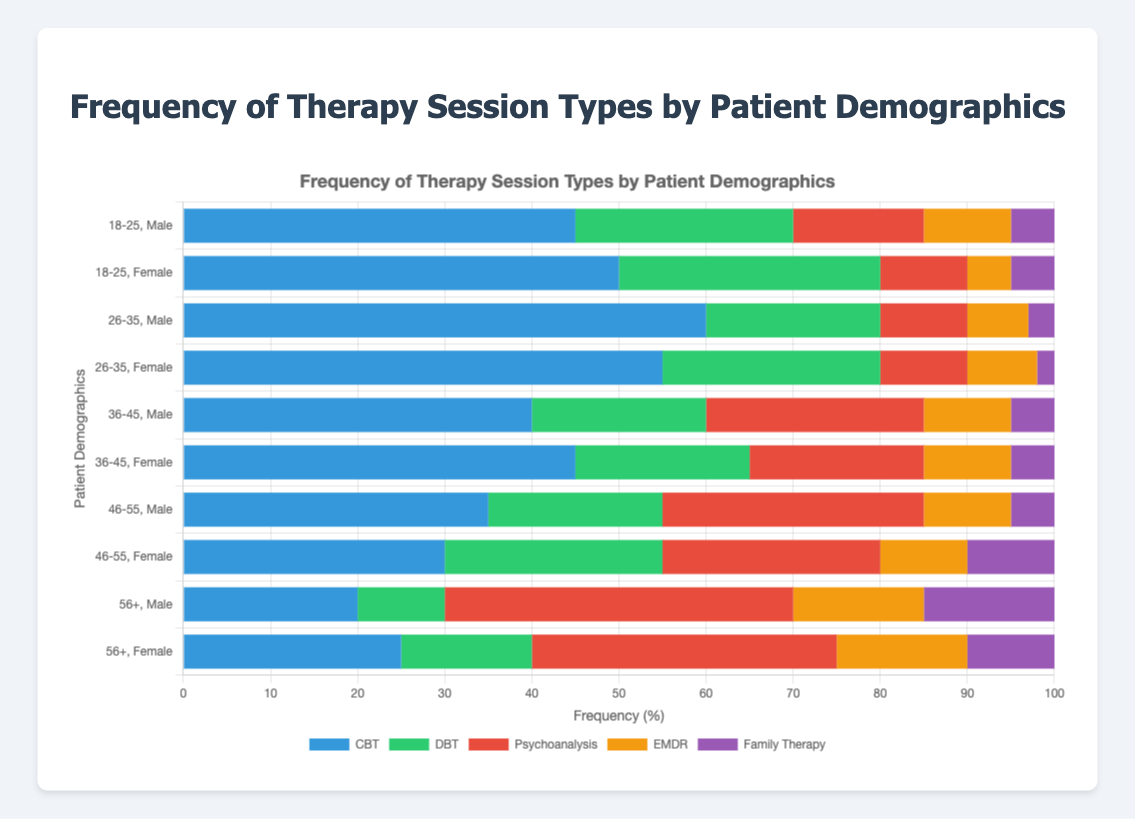What is the most common therapy type for males aged 26-35? To determine the most common therapy type for males aged 26-35, examine the bar length corresponding to each therapy for this demographic and identify the longest one. In this case, the longest bar is for CBT.
Answer: CBT How many more therapy sessions of CBT do females aged 18-25 attend compared to males aged 18-25? First, find the number of CBT sessions for females aged 18-25 (50) and males aged 18-25 (45). Then subtract the latter from the former (50 - 45 = 5).
Answer: 5 Which gender in the 36-45 age group has a higher frequency of Psychoanalysis sessions? Compare the lengths of the Psychoanalysis bars for 36-45 males and females. Males have 25 sessions, while females have 20. Thus, males have a higher frequency.
Answer: Male What is the total number of Family Therapy sessions for patients aged 56 and older? Add the number of Family Therapy sessions for males (15) and females (10) aged 56 and older. Total = 15 + 10 = 25.
Answer: 25 For which age group is DBT more commonly attended by females than males? Check each age group for the DBT bars and compare the lengths for males and females. DBT is more common for females in the 18-25 (30 vs. 25), 46-55 (25 vs. 20), and 56+ (15 vs. 10) age groups.
Answer: 18-25, 46-55, 56+ How does the frequency of EMDR sessions change with age for males? Examine the EMDR bars for males across different age groups and note any increase or decrease. It starts at 10 for 18-25, increases slightly to 15 for 56+. There is a decreasing trend between other age groups.
Answer: Slight overall increase What is the average frequency of CBT sessions across all demographics? Sum the CBT values for all demographics [(45 + 50 + 60 + 55 + 40 + 45 + 35 + 30 + 20 + 25) = 405]. Divide by the number of demographics (10). Average = 405 / 10 = 40.5.
Answer: 40.5 Which therapy type has the highest frequency for the 56+ age group? Compare the lengths of the bars for all therapy types within the 56+ age group. Psychoanalysis has the highest frequency for both males (40) and females (35).
Answer: Psychoanalysis In which age group do males attend DBT sessions more frequently than females? Compare the lengths of the DBT bars for males and females in each age group. Males attend DBT more frequently in the 26-35 age group (20 vs. 25).
Answer: 26-35 